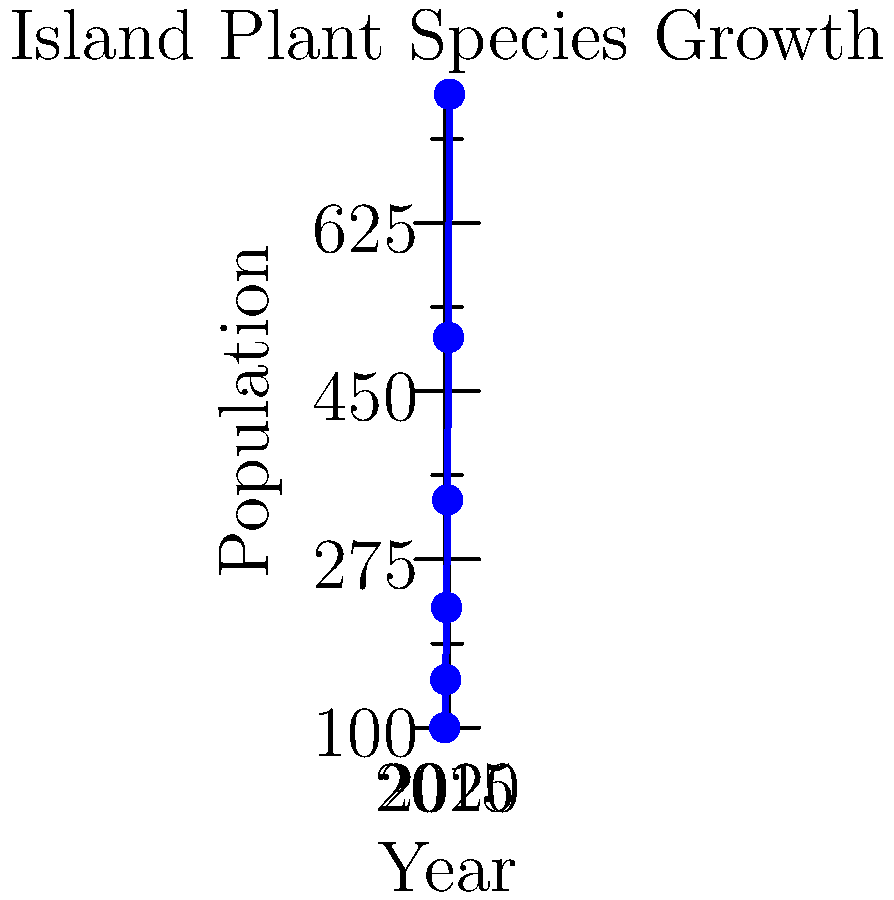A unique plant species on a remote island has been monitored for 6 years. The graph shows its population growth from 2015 to 2020. What type of growth pattern does this plant species exhibit, and approximately how many plants were there in 2018? To answer this question, we need to analyze the graph and identify the growth pattern:

1. Observe the curve: The line is not straight but curves upward, indicating an increasing rate of growth.

2. Calculate the growth rate:
   2015 to 2016: 50% increase (100 to 150)
   2016 to 2017: 50% increase (150 to 225)
   2017 to 2018: 50% increase (225 to 337)
   2018 to 2019: 50% increase (337 to 506)
   2019 to 2020: 50% increase (506 to 759)

3. Identify the pattern: The population increases by approximately 50% each year, which is characteristic of exponential growth.

4. Mathematical representation: The growth can be modeled by the equation $P(t) = P_0 \cdot (1.5)^t$, where $P_0$ is the initial population and $t$ is the number of years since 2015.

5. Population in 2018: From the graph, we can see that the population in 2018 is approximately 337 plants.

Therefore, the plant species exhibits exponential growth, and the population in 2018 was about 337 plants.
Answer: Exponential growth; 337 plants 